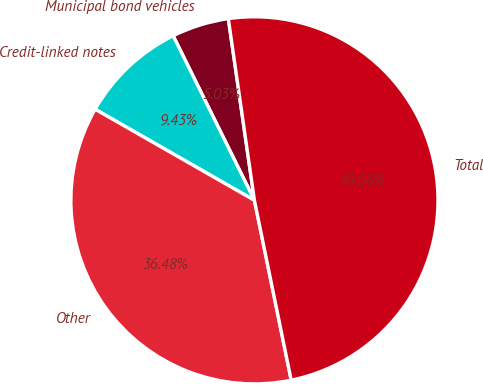Convert chart to OTSL. <chart><loc_0><loc_0><loc_500><loc_500><pie_chart><fcel>Municipal bond vehicles<fcel>Credit-linked notes<fcel>Other<fcel>Total<nl><fcel>5.03%<fcel>9.43%<fcel>36.48%<fcel>49.06%<nl></chart> 